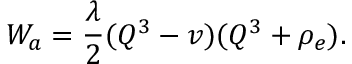<formula> <loc_0><loc_0><loc_500><loc_500>W _ { a } = \frac { \lambda } { 2 } ( Q ^ { 3 } - v ) ( Q ^ { 3 } + \rho _ { e } ) .</formula> 